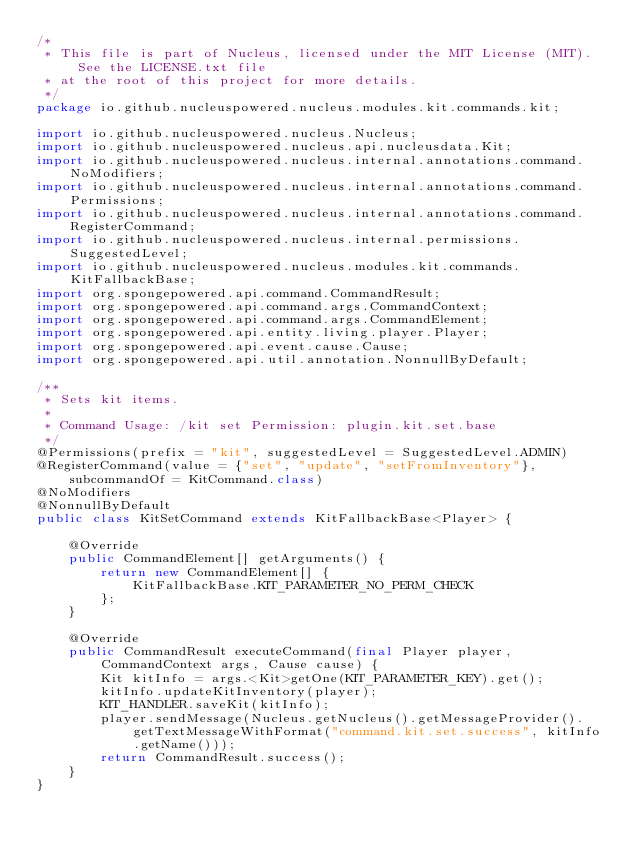<code> <loc_0><loc_0><loc_500><loc_500><_Java_>/*
 * This file is part of Nucleus, licensed under the MIT License (MIT). See the LICENSE.txt file
 * at the root of this project for more details.
 */
package io.github.nucleuspowered.nucleus.modules.kit.commands.kit;

import io.github.nucleuspowered.nucleus.Nucleus;
import io.github.nucleuspowered.nucleus.api.nucleusdata.Kit;
import io.github.nucleuspowered.nucleus.internal.annotations.command.NoModifiers;
import io.github.nucleuspowered.nucleus.internal.annotations.command.Permissions;
import io.github.nucleuspowered.nucleus.internal.annotations.command.RegisterCommand;
import io.github.nucleuspowered.nucleus.internal.permissions.SuggestedLevel;
import io.github.nucleuspowered.nucleus.modules.kit.commands.KitFallbackBase;
import org.spongepowered.api.command.CommandResult;
import org.spongepowered.api.command.args.CommandContext;
import org.spongepowered.api.command.args.CommandElement;
import org.spongepowered.api.entity.living.player.Player;
import org.spongepowered.api.event.cause.Cause;
import org.spongepowered.api.util.annotation.NonnullByDefault;

/**
 * Sets kit items.
 *
 * Command Usage: /kit set Permission: plugin.kit.set.base
 */
@Permissions(prefix = "kit", suggestedLevel = SuggestedLevel.ADMIN)
@RegisterCommand(value = {"set", "update", "setFromInventory"}, subcommandOf = KitCommand.class)
@NoModifiers
@NonnullByDefault
public class KitSetCommand extends KitFallbackBase<Player> {

    @Override
    public CommandElement[] getArguments() {
        return new CommandElement[] {
            KitFallbackBase.KIT_PARAMETER_NO_PERM_CHECK
        };
    }

    @Override
    public CommandResult executeCommand(final Player player, CommandContext args, Cause cause) {
        Kit kitInfo = args.<Kit>getOne(KIT_PARAMETER_KEY).get();
        kitInfo.updateKitInventory(player);
        KIT_HANDLER.saveKit(kitInfo);
        player.sendMessage(Nucleus.getNucleus().getMessageProvider().getTextMessageWithFormat("command.kit.set.success", kitInfo.getName()));
        return CommandResult.success();
    }
}
</code> 